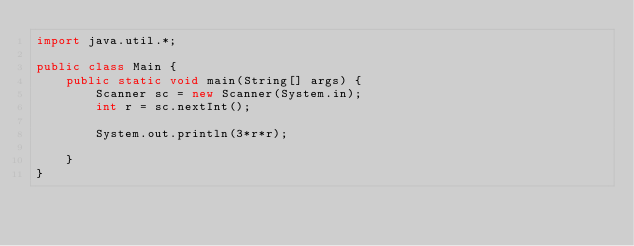<code> <loc_0><loc_0><loc_500><loc_500><_Java_>import java.util.*;

public class Main {
	public static void main(String[] args) {
    	Scanner sc = new Scanner(System.in);
      	int r = sc.nextInt();
      
      	System.out.println(3*r*r);
      
    }
}</code> 